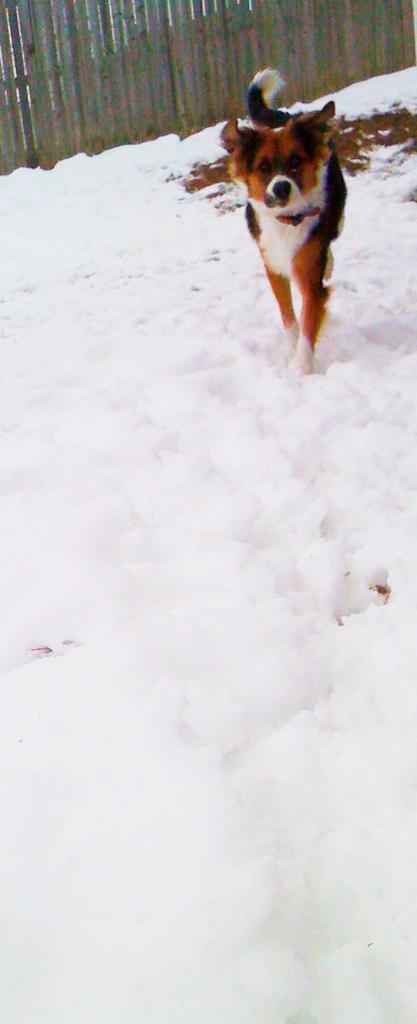Could you give a brief overview of what you see in this image? This picture is clicked outside. In the center there is an animal seems to be walking on the ground, the ground is covered with the snow. In the background we can see the objects which seems to be the wooden planks and we can see some object on the ground. 